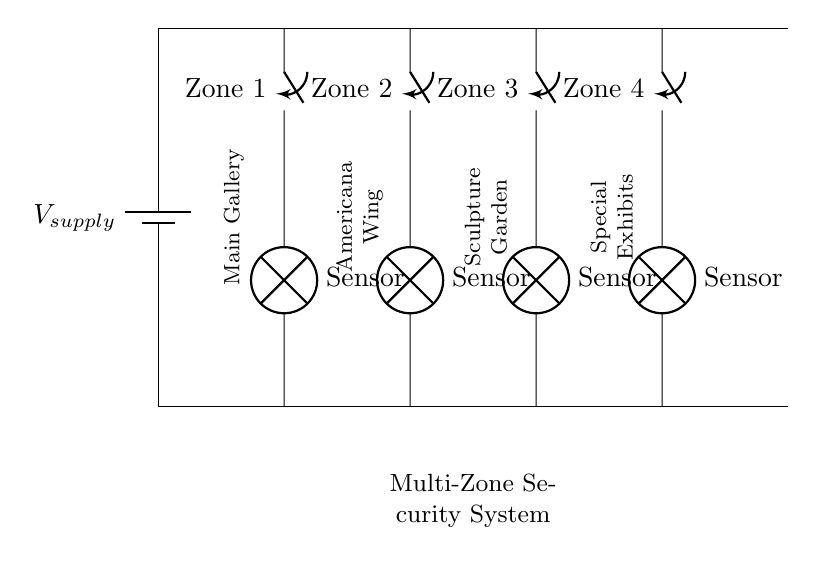what is the supply voltage of the circuit? The diagram does not specify an exact voltage value for the supply. It only indicates it as V_suppy, which typically represents a general potential.
Answer: V_supply how many zones are monitored in this security system? The circuit diagram shows four distinct switches, each labeled for a separate zone, indicating the number of monitored areas.
Answer: Four which component is used to detect unauthorized access in each zone? Each zone contains a lamp labeled as Sensor, which represents the detection mechanism for alarm response when a switch is activated.
Answer: Sensor if one zone's switch is closed, what happens to the other zones? In a parallel circuit, the current can still flow through other branches; therefore, the operation of one zone does not affect the others.
Answer: They remain operational how does the circuit indicate security status for each zone? Each zone has a switch that, when closed, activates the corresponding sensor lamp, visually indicating the security status for that zone.
Answer: By lamp activation what is the purpose of using a parallel circuit in this security system? A parallel circuit allows each zone to operate independently, ensuring that if one zone fails, the other zones remain functional, thus enhancing overall security.
Answer: Independent operation 